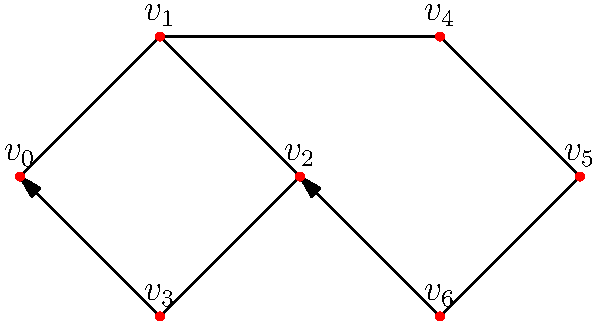Consider the directed graph representing a soccer team's formation and passing patterns. Vertices represent player positions, and edges represent possible passes between players. What is the in-degree of vertex $v_2$, and how might this information be useful for analyzing the team's strategy? To solve this problem, we need to follow these steps:

1. Understand the concept of in-degree:
   The in-degree of a vertex in a directed graph is the number of edges pointing towards that vertex.

2. Analyze the graph:
   - Look at vertex $v_2$ and count the number of arrows pointing towards it.
   - We can see that there are 2 arrows pointing towards $v_2$:
     a. One from $v_1$
     b. One from $v_6$

3. Calculate the in-degree:
   The in-degree of $v_2$ is 2.

4. Interpret the result in the context of soccer strategy:
   - An in-degree of 2 for $v_2$ suggests that this player position can receive passes from two other positions.
   - This could indicate that $v_2$ is a central or pivotal position in the team's formation, possibly a midfielder or a striker.
   - The player in position $v_2$ may have a crucial role in distributing the ball or acting as a target for passes from different areas of the field.
   - Coaches can use this information to:
     a. Identify key players who need to have good ball control and passing skills
     b. Develop strategies to exploit or protect this position, depending on whether it's in their team or the opponent's formation
     c. Analyze how the team's passing network might be disrupted if this player is marked closely by the opposition

By using graph theory to analyze team formations and passing patterns, coaches can gain valuable insights into their team's structure and potential strengths or weaknesses in their playing style.
Answer: 2; identifies key players and passing patterns 